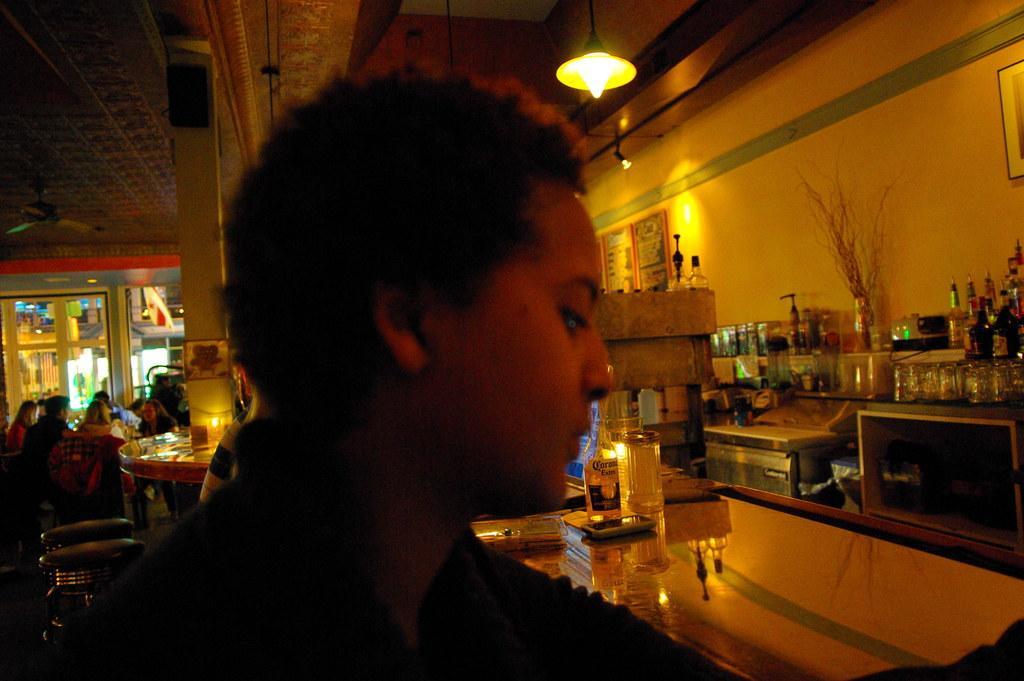Can you describe this image briefly? In this image we can see a person. On the right there is a table and we can see a bottle, mug, mobile and some objects placed on the table and there are bottles and glasses placed in the racks. In the background there are stools and we can see people sitting. At the top there are lights and we can see boards placed on the wall. 